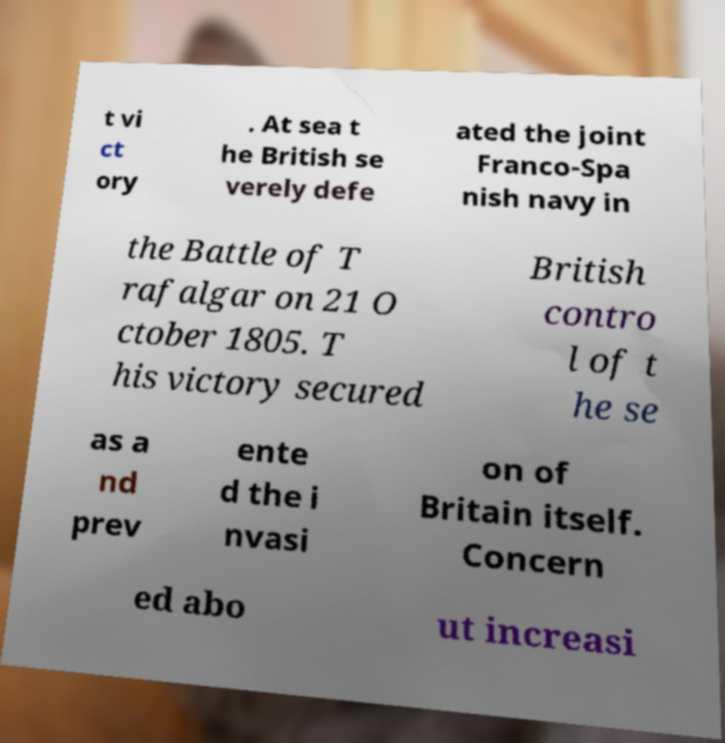Please identify and transcribe the text found in this image. t vi ct ory . At sea t he British se verely defe ated the joint Franco-Spa nish navy in the Battle of T rafalgar on 21 O ctober 1805. T his victory secured British contro l of t he se as a nd prev ente d the i nvasi on of Britain itself. Concern ed abo ut increasi 